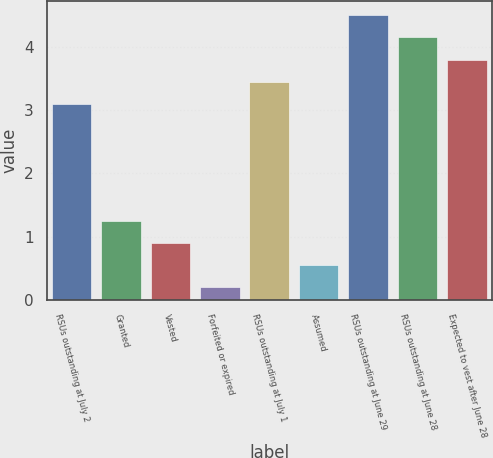<chart> <loc_0><loc_0><loc_500><loc_500><bar_chart><fcel>RSUs outstanding at July 2<fcel>Granted<fcel>Vested<fcel>Forfeited or expired<fcel>RSUs outstanding at July 1<fcel>Assumed<fcel>RSUs outstanding at June 29<fcel>RSUs outstanding at June 28<fcel>Expected to vest after June 28<nl><fcel>3.1<fcel>1.25<fcel>0.9<fcel>0.2<fcel>3.45<fcel>0.55<fcel>4.5<fcel>4.15<fcel>3.8<nl></chart> 